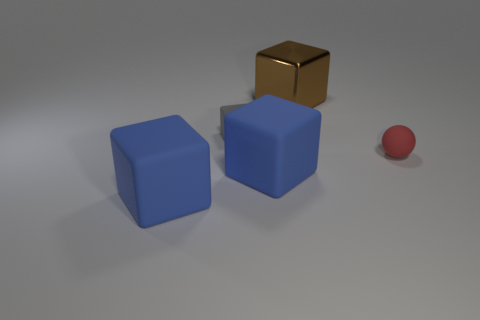What number of blocks are both in front of the red object and behind the tiny gray thing?
Offer a very short reply. 0. What number of large blue objects have the same material as the gray block?
Provide a short and direct response. 2. The other small object that is made of the same material as the red thing is what color?
Your response must be concise. Gray. Are there fewer gray cubes than blue matte things?
Make the answer very short. Yes. The blue cube that is left of the large blue object that is right of the blue matte block left of the small gray rubber object is made of what material?
Offer a terse response. Rubber. What is the large brown object made of?
Your response must be concise. Metal. There is a matte cube that is to the left of the small gray matte block; does it have the same color as the big rubber cube that is right of the tiny gray cube?
Provide a succinct answer. Yes. Are there more cylinders than objects?
Provide a short and direct response. No. How many large matte cubes have the same color as the small matte block?
Make the answer very short. 0. The large shiny object that is the same shape as the tiny gray object is what color?
Offer a terse response. Brown. 